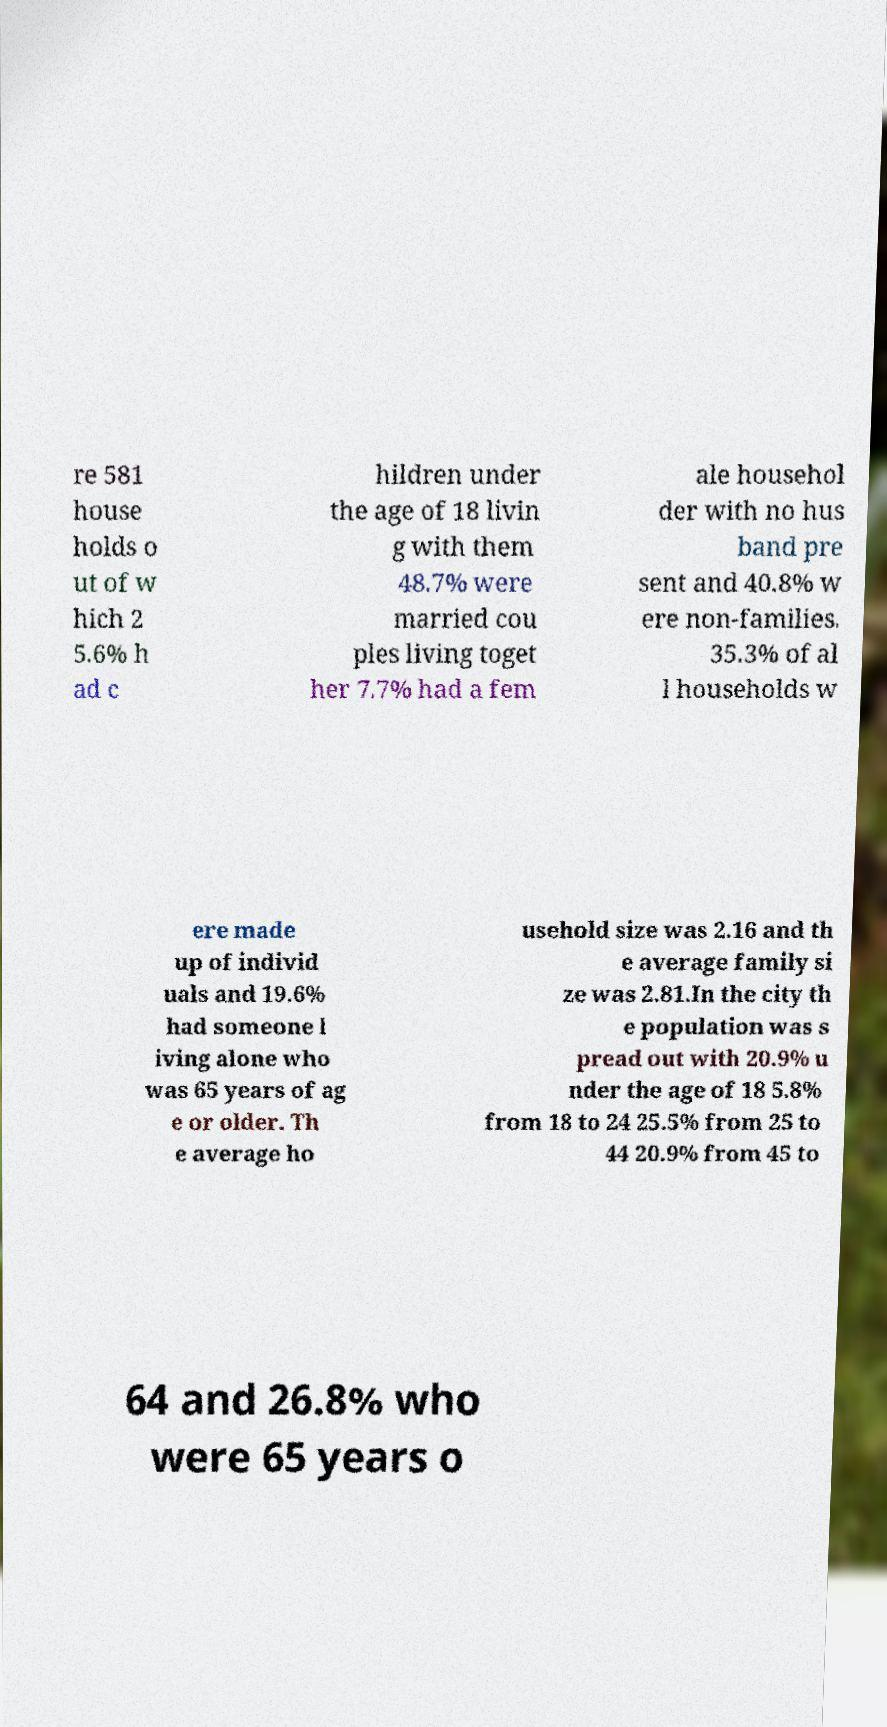Could you assist in decoding the text presented in this image and type it out clearly? re 581 house holds o ut of w hich 2 5.6% h ad c hildren under the age of 18 livin g with them 48.7% were married cou ples living toget her 7.7% had a fem ale househol der with no hus band pre sent and 40.8% w ere non-families. 35.3% of al l households w ere made up of individ uals and 19.6% had someone l iving alone who was 65 years of ag e or older. Th e average ho usehold size was 2.16 and th e average family si ze was 2.81.In the city th e population was s pread out with 20.9% u nder the age of 18 5.8% from 18 to 24 25.5% from 25 to 44 20.9% from 45 to 64 and 26.8% who were 65 years o 